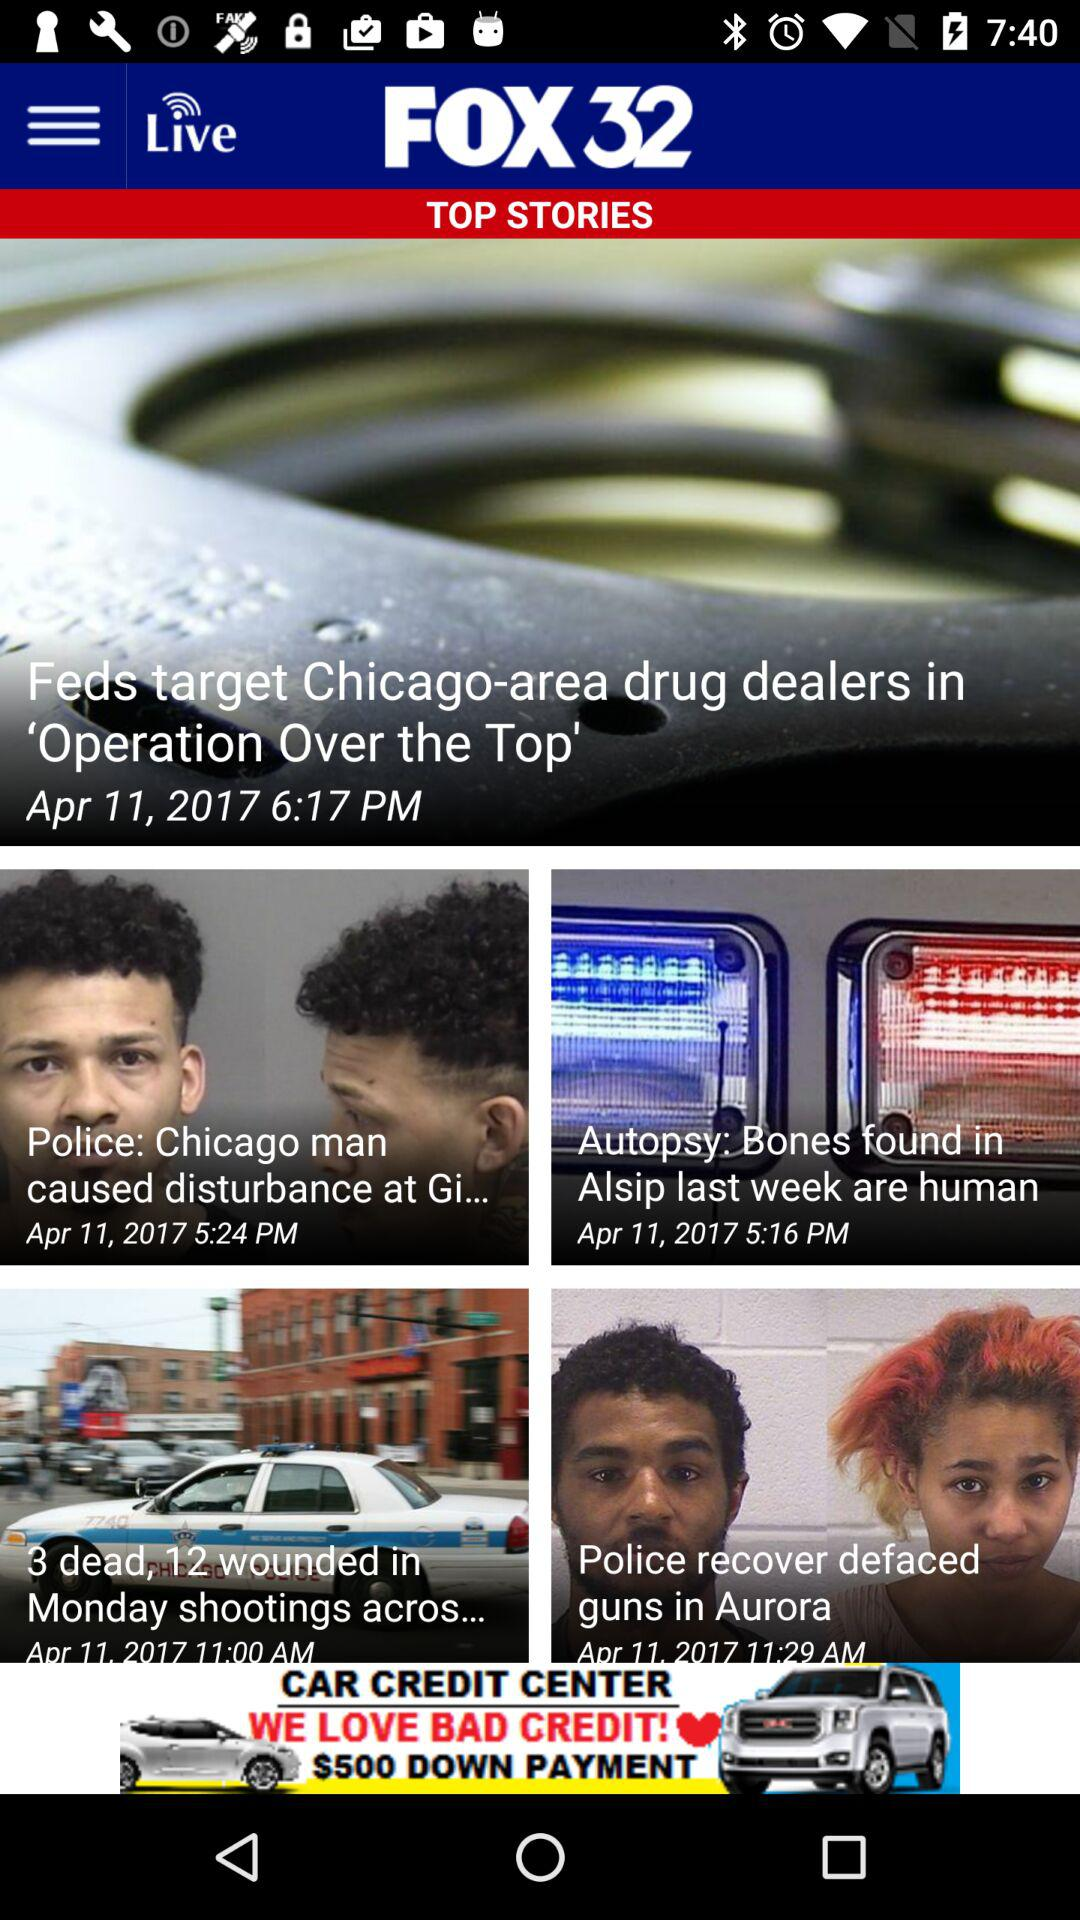At which time was the "Feds target Chicago-area drug dealers in 'Operation Over the Top'" news posted? The "Feds target Chicago-area drug dealers in 'Operation Over the Top'" news was posted at 6:17 p.m. 